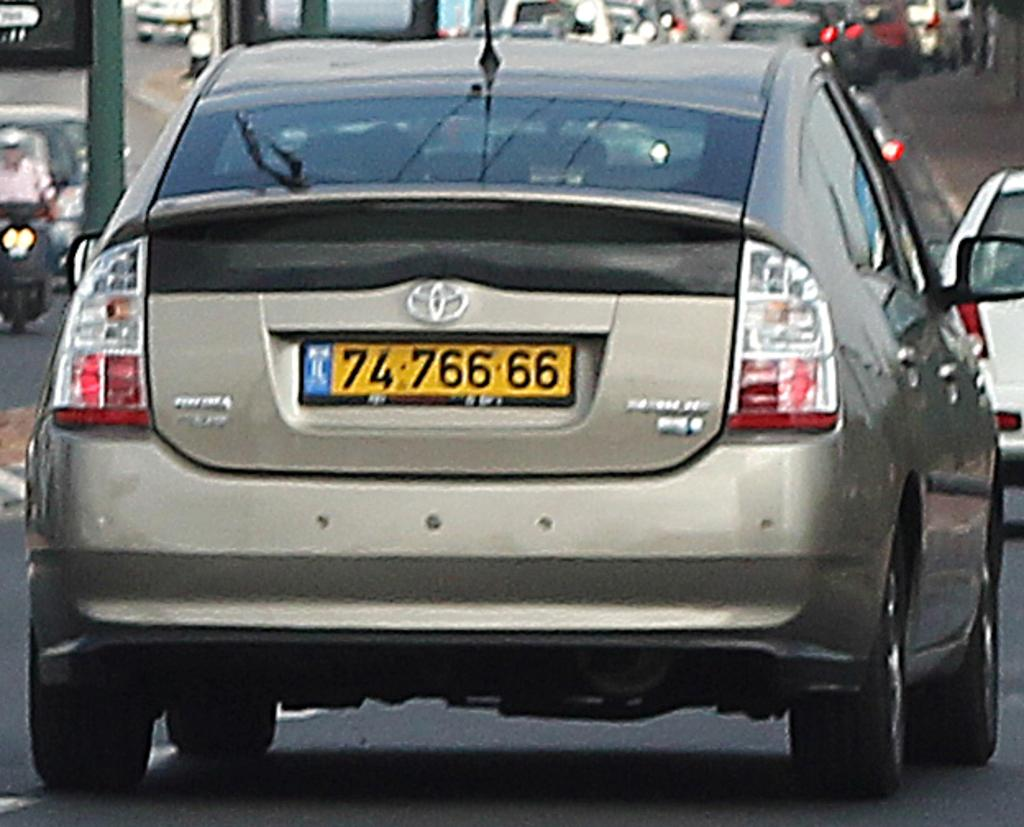<image>
Relay a brief, clear account of the picture shown. A tan Toyota Prius is in traffic and the license plate starts with 74. 